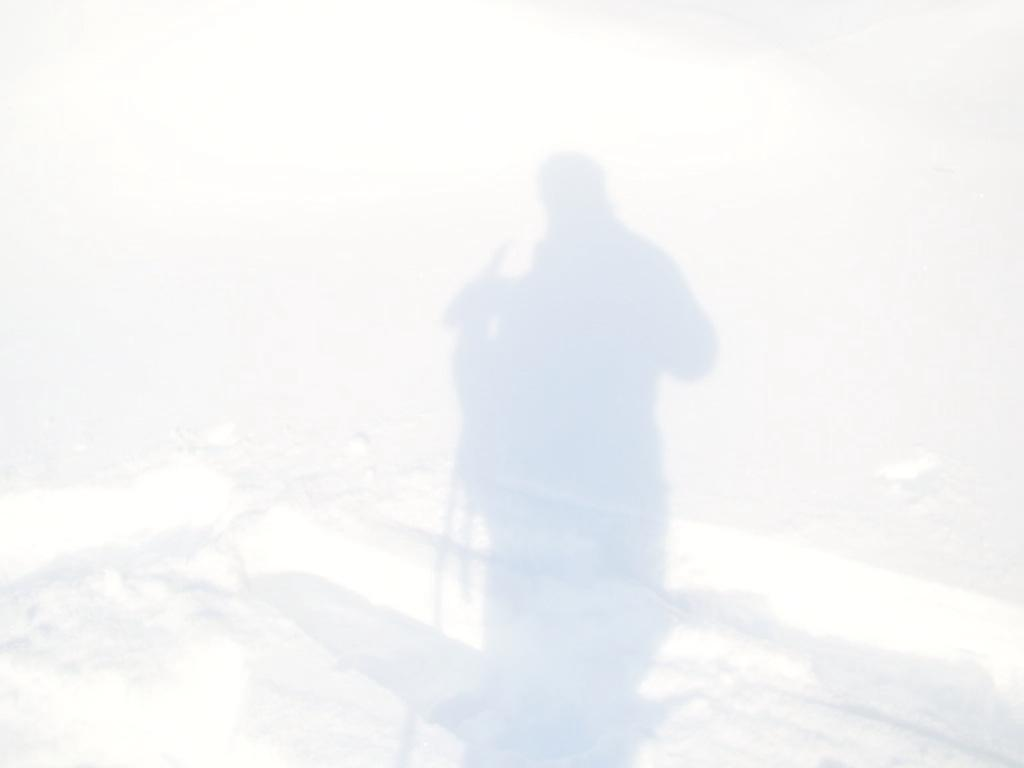What can be seen in the image besides the snow? There is a shadow of a person in the image. Where is the shadow located in the image? The shadow is on the snow. What type of farmer is supporting the shadow in the image? There is no farmer present in the image, and the shadow is not being supported by any person or object. What is the condition of the person's knee in the image? There is no person visible in the image, only their shadow, so we cannot determine the condition of their knee. 